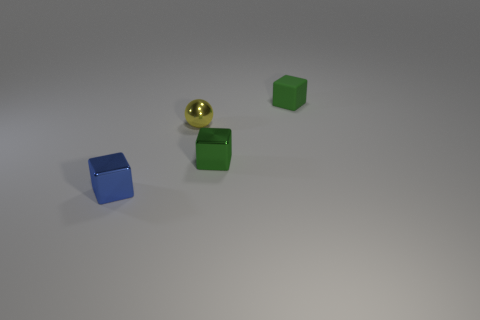Do the green thing behind the yellow sphere and the small blue object have the same shape?
Your answer should be very brief. Yes. What shape is the tiny green thing in front of the shiny object behind the metallic block behind the blue shiny block?
Offer a terse response. Cube. How many other objects are the same shape as the small blue object?
Offer a very short reply. 2. There is a matte cube; is it the same color as the tiny metal thing to the right of the small yellow shiny ball?
Your answer should be very brief. Yes. What number of metallic cubes are there?
Offer a terse response. 2. How many things are yellow metallic cubes or small green metallic blocks?
Keep it short and to the point. 1. The cube that is the same color as the rubber thing is what size?
Provide a short and direct response. Small. Are there any shiny blocks to the right of the blue metal cube?
Give a very brief answer. Yes. Is the number of yellow metallic spheres behind the tiny yellow metal object greater than the number of small blue shiny things right of the blue object?
Make the answer very short. No. There is another matte object that is the same shape as the blue object; what size is it?
Provide a short and direct response. Small. 